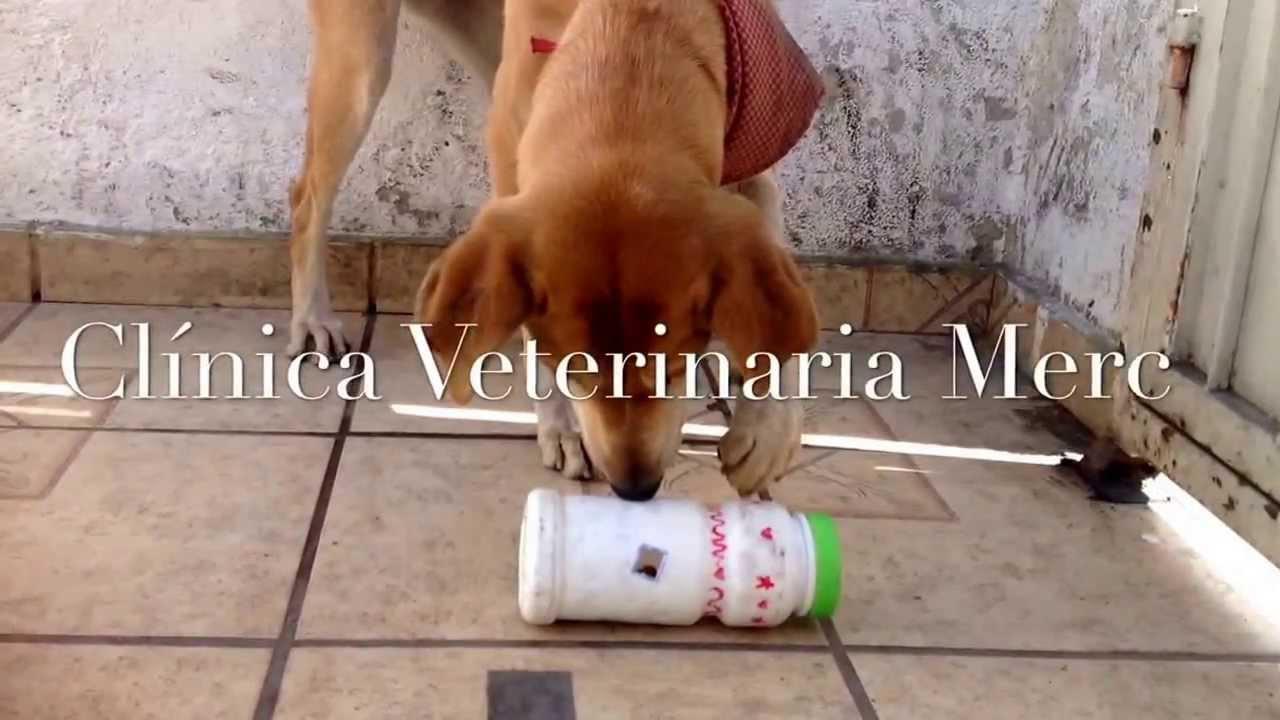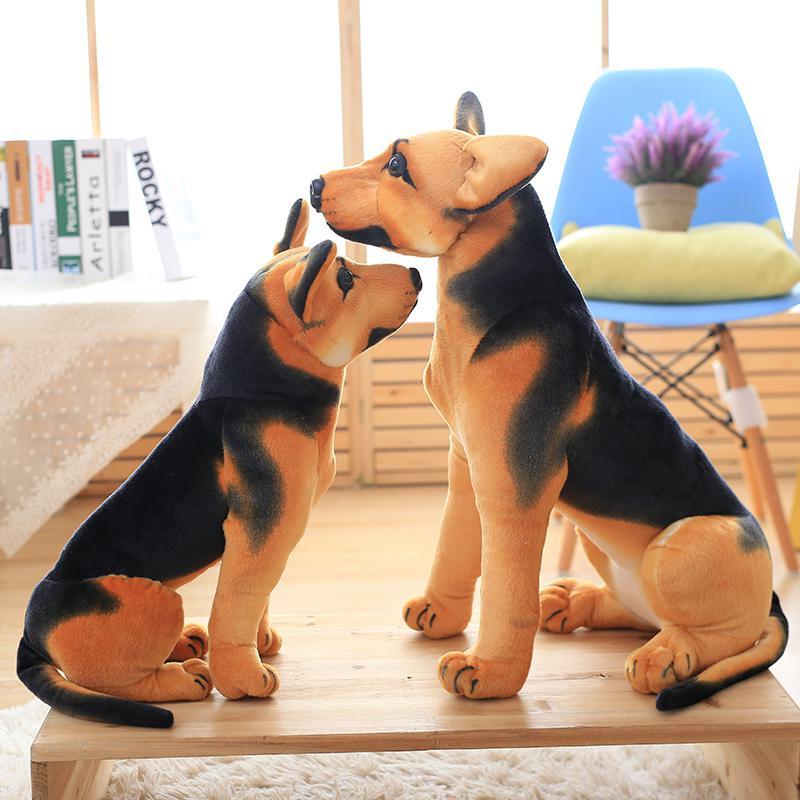The first image is the image on the left, the second image is the image on the right. Given the left and right images, does the statement "An image shows a cat crouched behind a bottle trimmed with blue curly ribbon." hold true? Answer yes or no. No. 